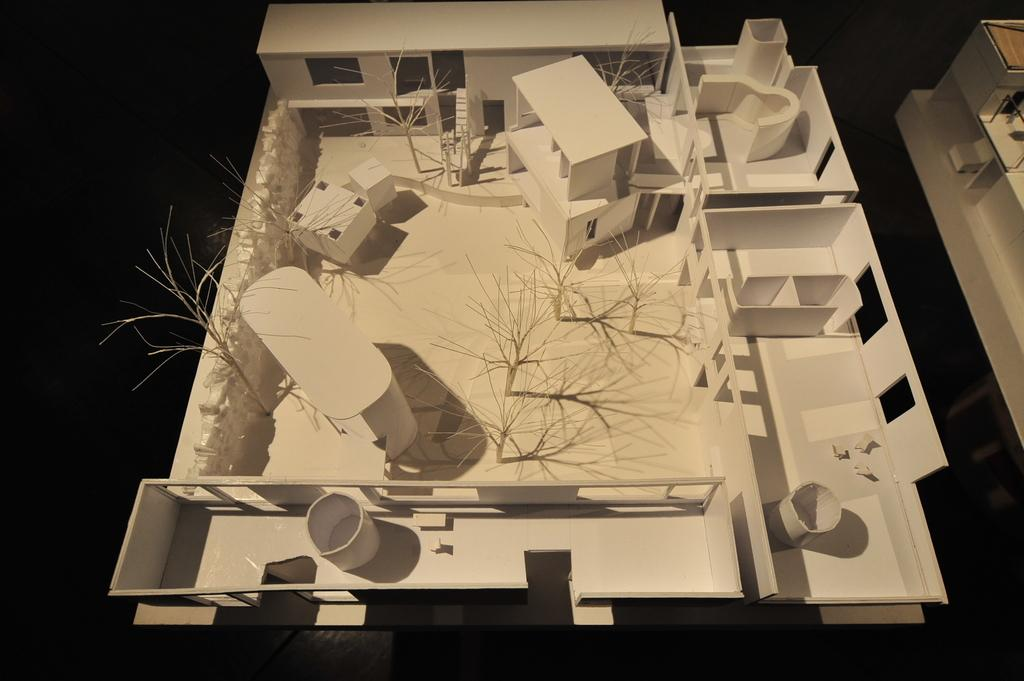What is the main subject of the image? There is a miniature house in the image. Can you describe the background of the image? The background of the image is dark. What can be seen on the left side of the image? There is a white object on the left side of the image. What type of record is being exchanged between the two people in the image? There are no people present in the image, and therefore no exchange of records can be observed. 